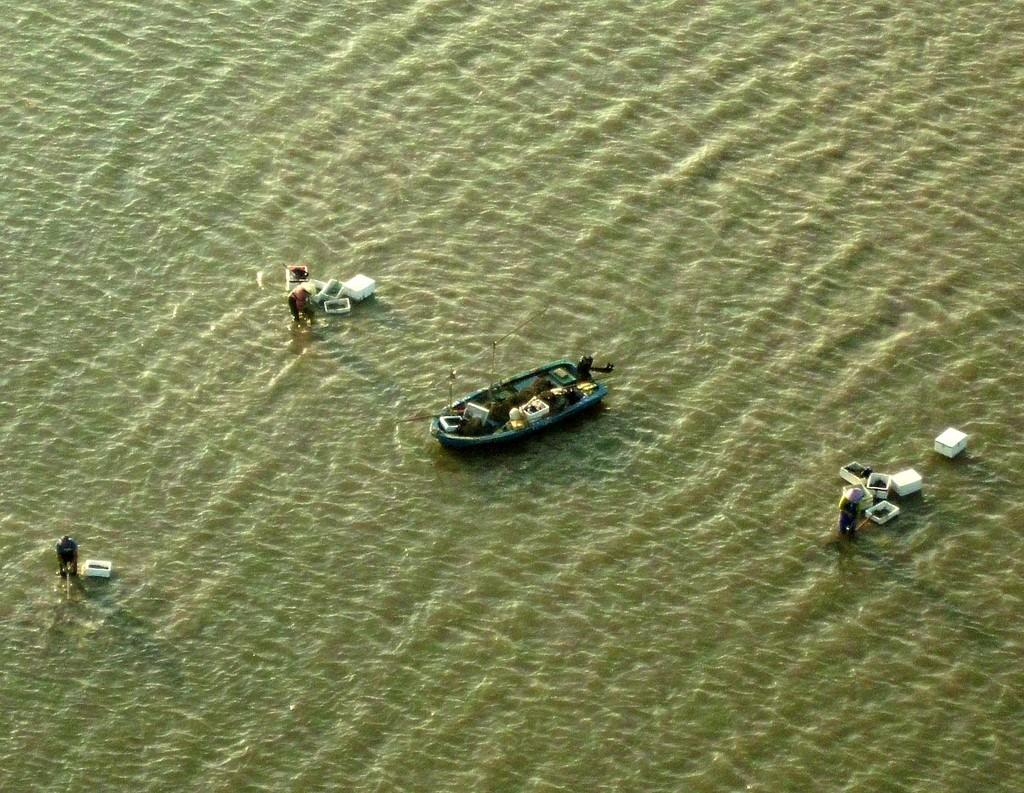How many people are in the image? There are three persons standing in the image. What is the main object in the image? There is a boat in the image. What else can be seen on the water besides the boat? There are boxes on the water in the image. What type of cloth is being used to cover the base of the boat in the image? There is no cloth or base of the boat visible in the image. 